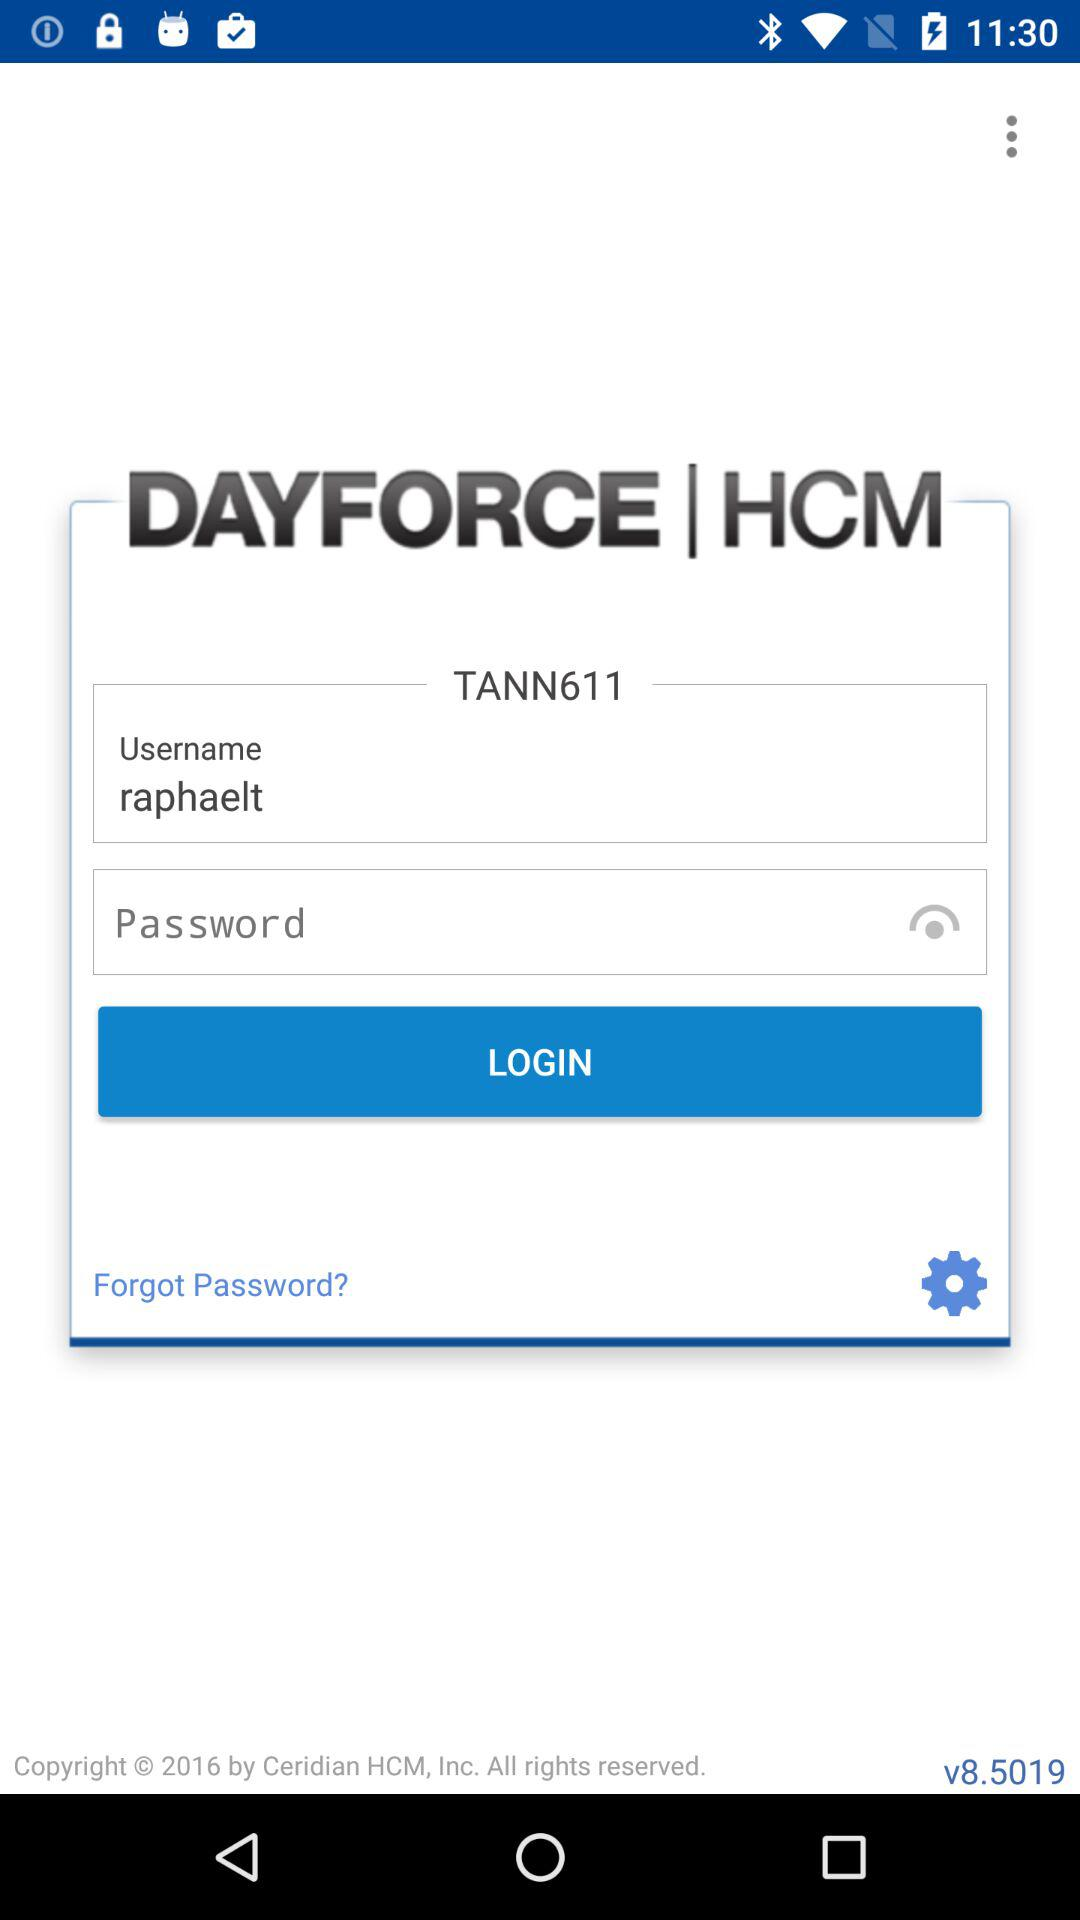What is the name of the application? The name of the application is "DAYFORCE HCM". 